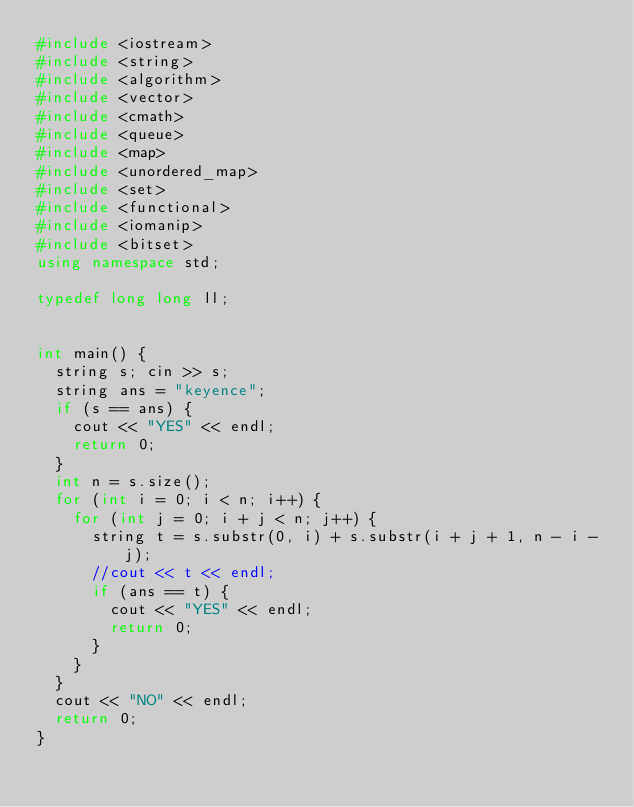<code> <loc_0><loc_0><loc_500><loc_500><_C++_>#include <iostream>
#include <string>
#include <algorithm>
#include <vector>
#include <cmath>
#include <queue>
#include <map>
#include <unordered_map>
#include <set>
#include <functional>
#include <iomanip>
#include <bitset>
using namespace std;

typedef long long ll;


int main() {
	string s; cin >> s;
	string ans = "keyence";
	if (s == ans) {
		cout << "YES" << endl;
		return 0;
	}
	int n = s.size();
	for (int i = 0; i < n; i++) {
		for (int j = 0; i + j < n; j++) {
			string t = s.substr(0, i) + s.substr(i + j + 1, n - i - j);
			//cout << t << endl;
			if (ans == t) {
				cout << "YES" << endl;
				return 0;
			}
		}
	}
	cout << "NO" << endl;
	return 0;
}
</code> 